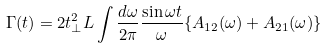<formula> <loc_0><loc_0><loc_500><loc_500>\Gamma ( t ) = 2 t _ { \perp } ^ { 2 } L \int \frac { d \omega } { 2 \pi } \frac { \sin \omega t } { \omega } \{ A _ { 1 2 } ( \omega ) + A _ { 2 1 } ( \omega ) \}</formula> 